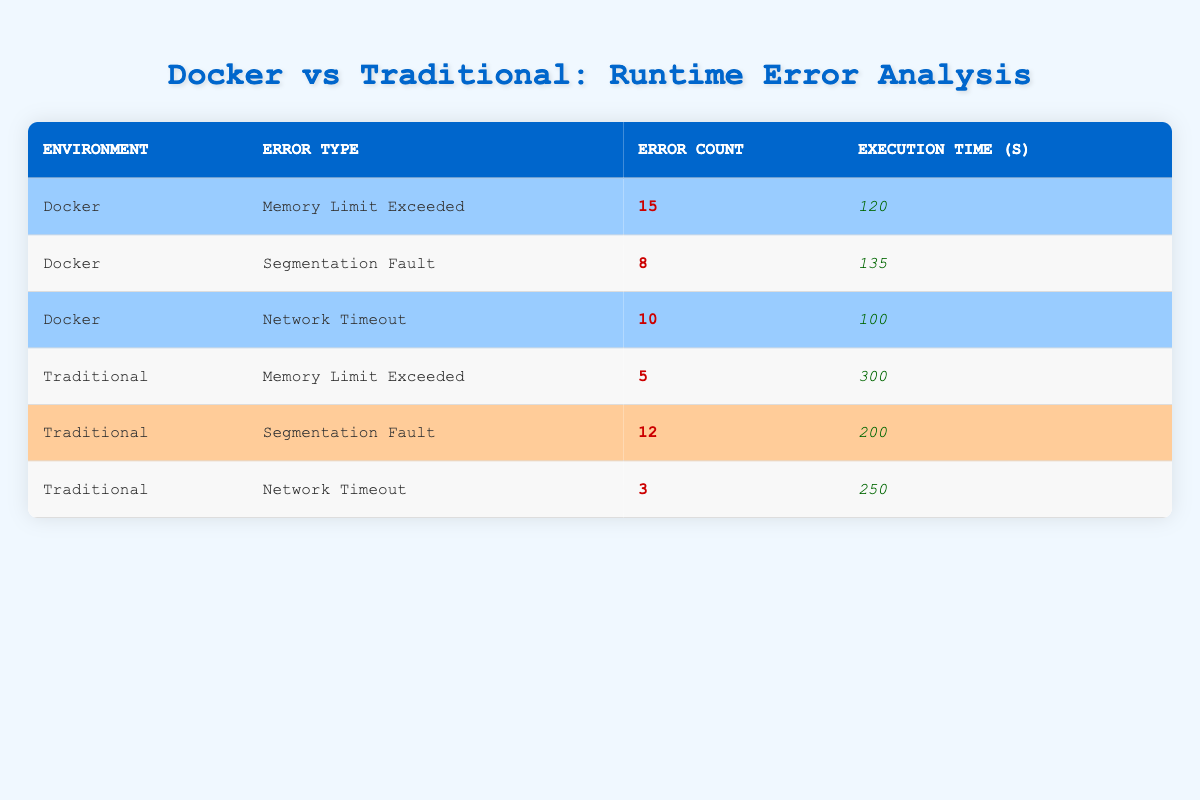What is the error count for "Segmentation Fault" in the Docker environment? In the Docker environment, we look for the row where the error type is "Segmentation Fault". The table shows that there are 8 errors for this type in the Docker section.
Answer: 8 What is the execution time for "Memory Limit Exceeded" in the Traditional environment? We check the row for "Memory Limit Exceeded" under the Traditional environment. The provided execution time in the table is 300 seconds.
Answer: 300 Which environment has more "Network Timeout" errors? We compare the error counts for "Network Timeout" in both environments. Docker has 10 errors, while Traditional has 3 errors. Therefore, Docker has more "Network Timeout" errors.
Answer: Docker What is the total number of errors across both environments? To find the total number of errors, we sum the error counts from all rows: (15 + 8 + 10 + 5 + 12 + 3) = 53. Thus, the total number of errors across both environments is 53.
Answer: 53 What is the average execution time of errors in the Docker environment? We look at the execution times for Docker which are 120, 135, and 100 seconds respectively. First, we add these up: (120 + 135 + 100) = 355 seconds. Then, since there are 3 errors, we divide 355 by 3, yielding approximately 118.33 seconds.
Answer: 118.33 Is the execution time for "Segmentation Fault" in the Traditional environment less than the execution time for "Network Timeout" in the Docker environment? The execution time for "Segmentation Fault" in Traditional is 200 seconds, while the "Network Timeout" in Docker is 100 seconds. Since 200 is not less than 100, the statement is false.
Answer: No What is the difference in error count for "Memory Limit Exceeded" errors between Docker and Traditional environments? In the Docker environment, the "Memory Limit Exceeded" error count is 15, while in Traditional it is 5. The difference is calculated as (15 - 5) = 10.
Answer: 10 Which error type has the highest execution time in the Traditional environment? Looking through the execution times for Traditional errors, we find 300 seconds for "Memory Limit Exceeded", 200 seconds for "Segmentation Fault", and 250 seconds for "Network Timeout". The highest execution time is 300 seconds for "Memory Limit Exceeded".
Answer: Memory Limit Exceeded 